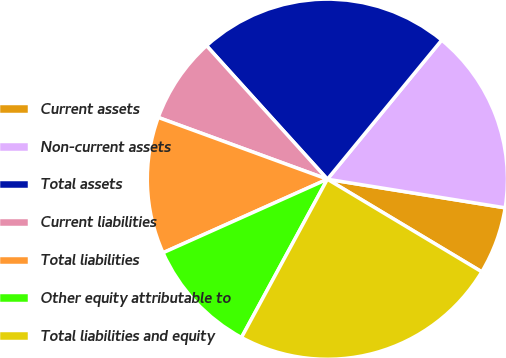Convert chart. <chart><loc_0><loc_0><loc_500><loc_500><pie_chart><fcel>Current assets<fcel>Non-current assets<fcel>Total assets<fcel>Current liabilities<fcel>Total liabilities<fcel>Other equity attributable to<fcel>Total liabilities and equity<nl><fcel>6.06%<fcel>16.59%<fcel>22.65%<fcel>7.72%<fcel>12.27%<fcel>10.39%<fcel>24.31%<nl></chart> 